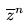Convert formula to latex. <formula><loc_0><loc_0><loc_500><loc_500>\overline { z } ^ { n }</formula> 